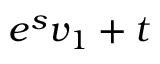Convert formula to latex. <formula><loc_0><loc_0><loc_500><loc_500>e ^ { s } v _ { 1 } + t</formula> 